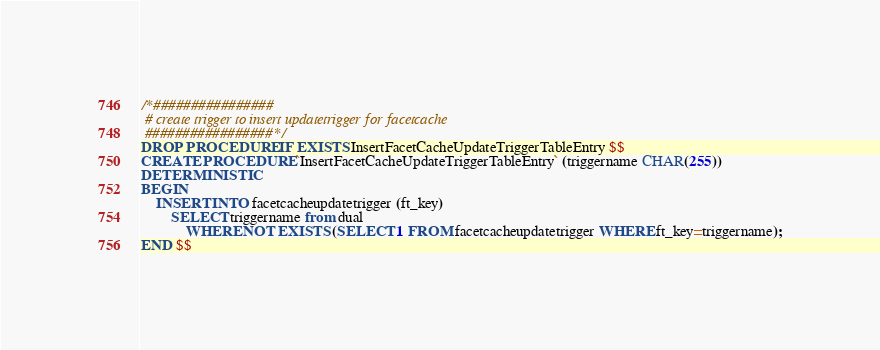<code> <loc_0><loc_0><loc_500><loc_500><_SQL_>/*################
 # create trigger to insert updatetrigger for facetcache
 #################*/
DROP PROCEDURE IF EXISTS InsertFacetCacheUpdateTriggerTableEntry $$
CREATE PROCEDURE `InsertFacetCacheUpdateTriggerTableEntry` (triggername CHAR(255))
DETERMINISTIC
BEGIN
    INSERT INTO facetcacheupdatetrigger (ft_key)
        SELECT triggername from dual
            WHERE NOT EXISTS (SELECT 1 FROM facetcacheupdatetrigger WHERE ft_key=triggername);
END $$
</code> 